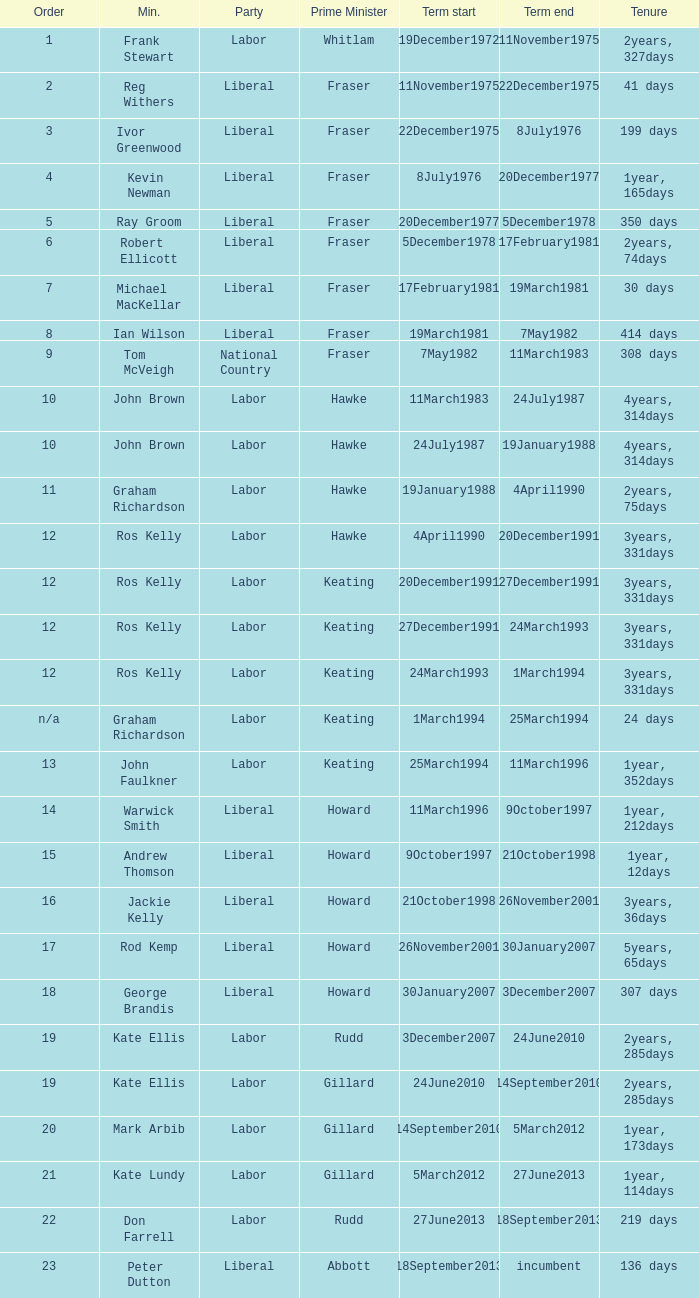What is the Term in office with an Order that is 9? 308 days. 